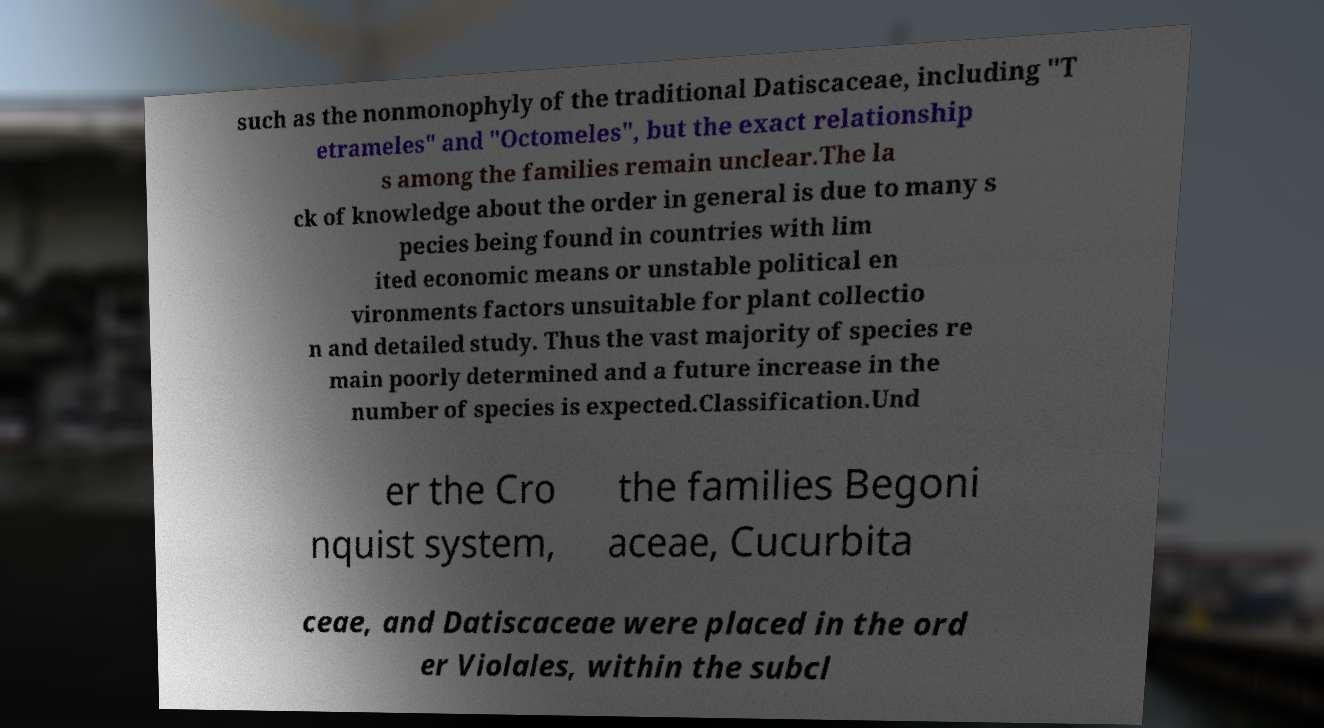I need the written content from this picture converted into text. Can you do that? such as the nonmonophyly of the traditional Datiscaceae, including "T etrameles" and "Octomeles", but the exact relationship s among the families remain unclear.The la ck of knowledge about the order in general is due to many s pecies being found in countries with lim ited economic means or unstable political en vironments factors unsuitable for plant collectio n and detailed study. Thus the vast majority of species re main poorly determined and a future increase in the number of species is expected.Classification.Und er the Cro nquist system, the families Begoni aceae, Cucurbita ceae, and Datiscaceae were placed in the ord er Violales, within the subcl 